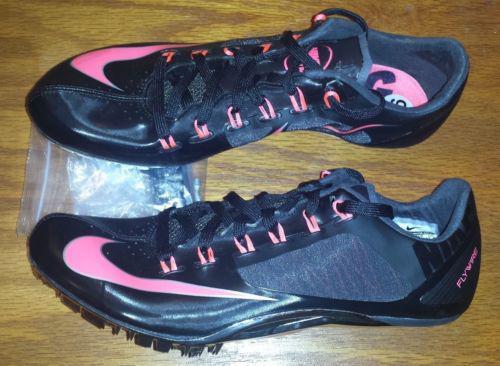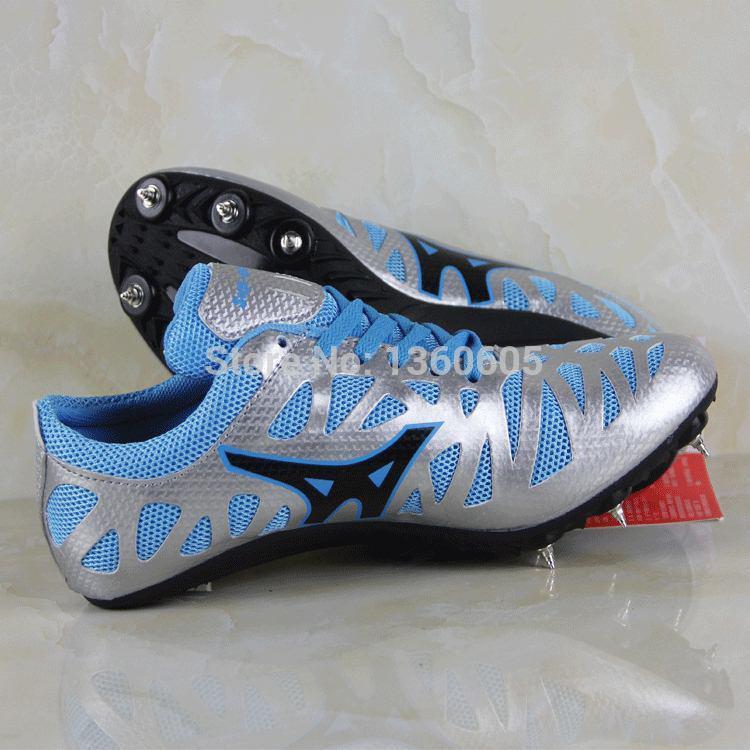The first image is the image on the left, the second image is the image on the right. For the images shown, is this caption "One image contains a single, mostly blue shoe, and the other image shows a pair of shoes, one with its sole turned to the camera." true? Answer yes or no. No. The first image is the image on the left, the second image is the image on the right. Given the left and right images, does the statement "The right image contains exactly one blue sports tennis shoe." hold true? Answer yes or no. No. 